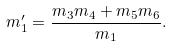<formula> <loc_0><loc_0><loc_500><loc_500>m ^ { \prime } _ { 1 } = \frac { m _ { 3 } m _ { 4 } + m _ { 5 } m _ { 6 } } { m _ { 1 } } .</formula> 